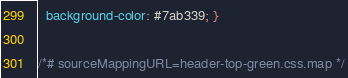<code> <loc_0><loc_0><loc_500><loc_500><_CSS_>  background-color: #7ab339; }

/*# sourceMappingURL=header-top-green.css.map */
</code> 